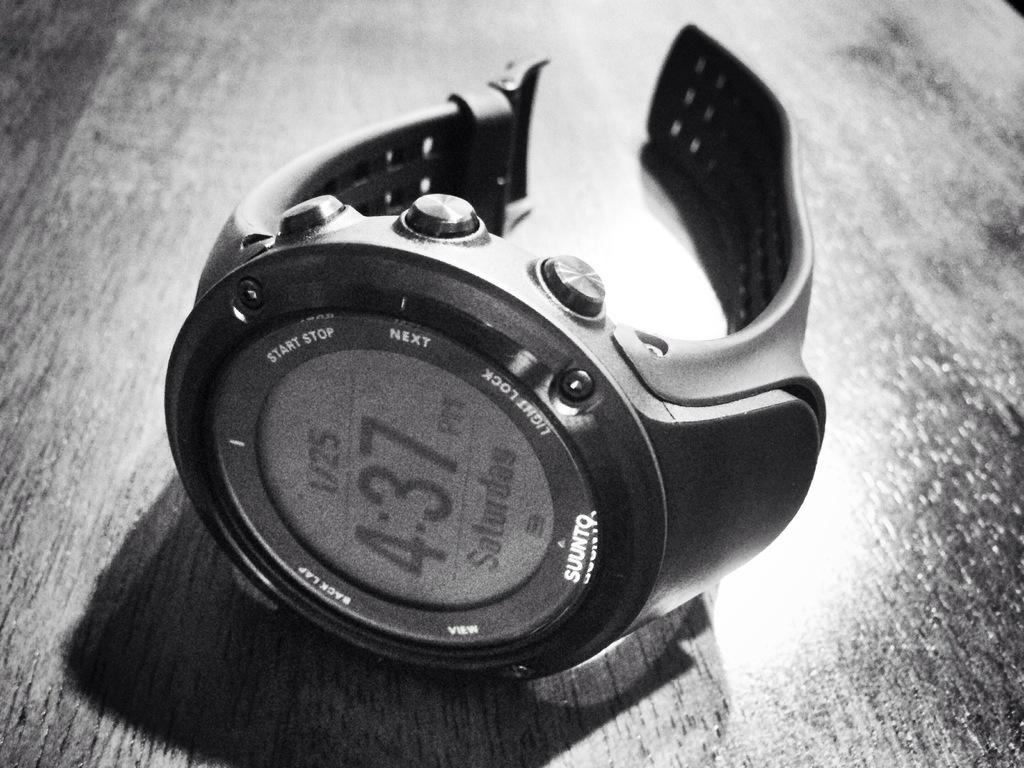What type of watch brand is this?
Your response must be concise. Suunto. What time does the watch read?
Give a very brief answer. 4:37. 